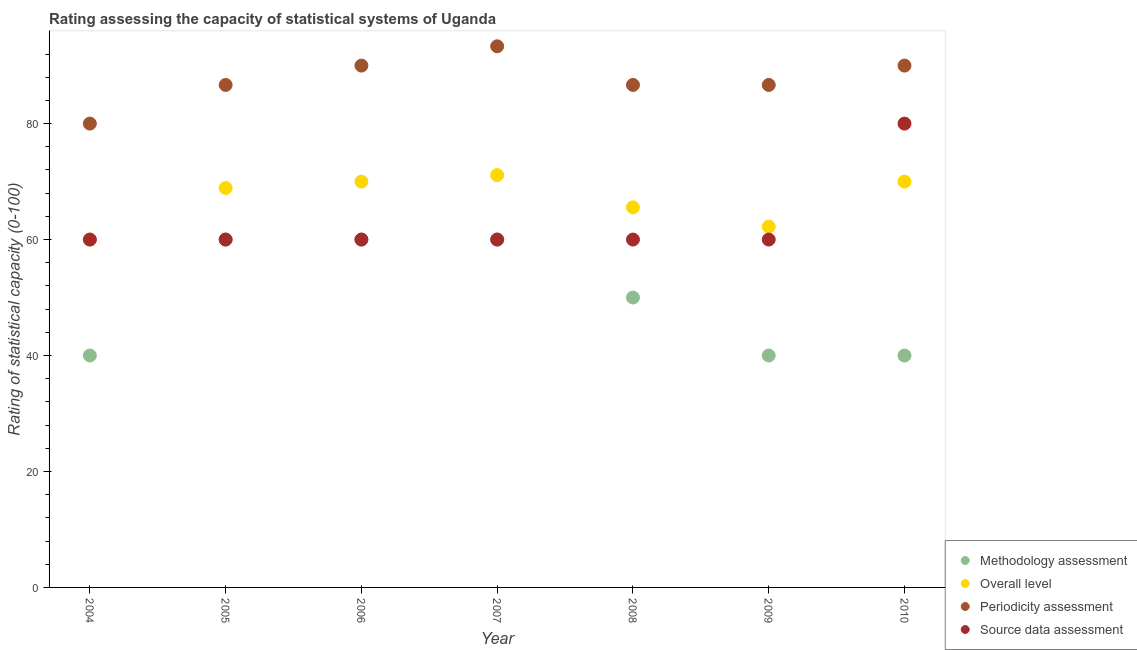How many different coloured dotlines are there?
Keep it short and to the point. 4. What is the source data assessment rating in 2008?
Your answer should be compact. 60. Across all years, what is the maximum overall level rating?
Keep it short and to the point. 71.11. Across all years, what is the minimum source data assessment rating?
Your answer should be compact. 60. In which year was the methodology assessment rating minimum?
Ensure brevity in your answer.  2004. What is the total overall level rating in the graph?
Ensure brevity in your answer.  467.78. What is the difference between the periodicity assessment rating in 2009 and that in 2010?
Ensure brevity in your answer.  -3.33. What is the difference between the periodicity assessment rating in 2005 and the source data assessment rating in 2009?
Ensure brevity in your answer.  26.67. What is the difference between the highest and the second highest source data assessment rating?
Keep it short and to the point. 20. What is the difference between the highest and the lowest source data assessment rating?
Offer a very short reply. 20. In how many years, is the overall level rating greater than the average overall level rating taken over all years?
Your response must be concise. 4. Is it the case that in every year, the sum of the methodology assessment rating and source data assessment rating is greater than the sum of periodicity assessment rating and overall level rating?
Your answer should be compact. No. Does the source data assessment rating monotonically increase over the years?
Provide a succinct answer. No. Is the source data assessment rating strictly greater than the overall level rating over the years?
Ensure brevity in your answer.  No. How many dotlines are there?
Offer a terse response. 4. What is the difference between two consecutive major ticks on the Y-axis?
Your answer should be very brief. 20. Are the values on the major ticks of Y-axis written in scientific E-notation?
Provide a short and direct response. No. Does the graph contain any zero values?
Your answer should be very brief. No. Where does the legend appear in the graph?
Your answer should be very brief. Bottom right. What is the title of the graph?
Your answer should be compact. Rating assessing the capacity of statistical systems of Uganda. What is the label or title of the X-axis?
Your response must be concise. Year. What is the label or title of the Y-axis?
Provide a short and direct response. Rating of statistical capacity (0-100). What is the Rating of statistical capacity (0-100) in Periodicity assessment in 2004?
Give a very brief answer. 80. What is the Rating of statistical capacity (0-100) in Source data assessment in 2004?
Offer a very short reply. 60. What is the Rating of statistical capacity (0-100) of Methodology assessment in 2005?
Offer a terse response. 60. What is the Rating of statistical capacity (0-100) in Overall level in 2005?
Make the answer very short. 68.89. What is the Rating of statistical capacity (0-100) of Periodicity assessment in 2005?
Make the answer very short. 86.67. What is the Rating of statistical capacity (0-100) of Source data assessment in 2005?
Offer a very short reply. 60. What is the Rating of statistical capacity (0-100) in Overall level in 2006?
Your answer should be very brief. 70. What is the Rating of statistical capacity (0-100) in Periodicity assessment in 2006?
Keep it short and to the point. 90. What is the Rating of statistical capacity (0-100) in Overall level in 2007?
Your answer should be very brief. 71.11. What is the Rating of statistical capacity (0-100) in Periodicity assessment in 2007?
Provide a succinct answer. 93.33. What is the Rating of statistical capacity (0-100) of Methodology assessment in 2008?
Your answer should be very brief. 50. What is the Rating of statistical capacity (0-100) of Overall level in 2008?
Keep it short and to the point. 65.56. What is the Rating of statistical capacity (0-100) in Periodicity assessment in 2008?
Offer a terse response. 86.67. What is the Rating of statistical capacity (0-100) of Source data assessment in 2008?
Offer a terse response. 60. What is the Rating of statistical capacity (0-100) in Overall level in 2009?
Your response must be concise. 62.22. What is the Rating of statistical capacity (0-100) in Periodicity assessment in 2009?
Give a very brief answer. 86.67. What is the Rating of statistical capacity (0-100) of Source data assessment in 2009?
Your answer should be compact. 60. What is the Rating of statistical capacity (0-100) of Source data assessment in 2010?
Give a very brief answer. 80. Across all years, what is the maximum Rating of statistical capacity (0-100) of Overall level?
Provide a short and direct response. 71.11. Across all years, what is the maximum Rating of statistical capacity (0-100) of Periodicity assessment?
Your answer should be very brief. 93.33. Across all years, what is the minimum Rating of statistical capacity (0-100) of Methodology assessment?
Your answer should be very brief. 40. Across all years, what is the minimum Rating of statistical capacity (0-100) in Periodicity assessment?
Offer a terse response. 80. Across all years, what is the minimum Rating of statistical capacity (0-100) of Source data assessment?
Provide a succinct answer. 60. What is the total Rating of statistical capacity (0-100) in Methodology assessment in the graph?
Give a very brief answer. 350. What is the total Rating of statistical capacity (0-100) in Overall level in the graph?
Your answer should be compact. 467.78. What is the total Rating of statistical capacity (0-100) in Periodicity assessment in the graph?
Your answer should be compact. 613.33. What is the total Rating of statistical capacity (0-100) in Source data assessment in the graph?
Make the answer very short. 440. What is the difference between the Rating of statistical capacity (0-100) in Methodology assessment in 2004 and that in 2005?
Keep it short and to the point. -20. What is the difference between the Rating of statistical capacity (0-100) of Overall level in 2004 and that in 2005?
Your answer should be very brief. -8.89. What is the difference between the Rating of statistical capacity (0-100) in Periodicity assessment in 2004 and that in 2005?
Your answer should be very brief. -6.67. What is the difference between the Rating of statistical capacity (0-100) in Source data assessment in 2004 and that in 2005?
Offer a terse response. 0. What is the difference between the Rating of statistical capacity (0-100) in Methodology assessment in 2004 and that in 2007?
Make the answer very short. -20. What is the difference between the Rating of statistical capacity (0-100) in Overall level in 2004 and that in 2007?
Give a very brief answer. -11.11. What is the difference between the Rating of statistical capacity (0-100) in Periodicity assessment in 2004 and that in 2007?
Ensure brevity in your answer.  -13.33. What is the difference between the Rating of statistical capacity (0-100) in Overall level in 2004 and that in 2008?
Keep it short and to the point. -5.56. What is the difference between the Rating of statistical capacity (0-100) of Periodicity assessment in 2004 and that in 2008?
Keep it short and to the point. -6.67. What is the difference between the Rating of statistical capacity (0-100) of Source data assessment in 2004 and that in 2008?
Offer a terse response. 0. What is the difference between the Rating of statistical capacity (0-100) of Overall level in 2004 and that in 2009?
Give a very brief answer. -2.22. What is the difference between the Rating of statistical capacity (0-100) of Periodicity assessment in 2004 and that in 2009?
Provide a succinct answer. -6.67. What is the difference between the Rating of statistical capacity (0-100) of Source data assessment in 2004 and that in 2009?
Your response must be concise. 0. What is the difference between the Rating of statistical capacity (0-100) of Periodicity assessment in 2004 and that in 2010?
Give a very brief answer. -10. What is the difference between the Rating of statistical capacity (0-100) in Source data assessment in 2004 and that in 2010?
Make the answer very short. -20. What is the difference between the Rating of statistical capacity (0-100) in Overall level in 2005 and that in 2006?
Make the answer very short. -1.11. What is the difference between the Rating of statistical capacity (0-100) in Source data assessment in 2005 and that in 2006?
Ensure brevity in your answer.  0. What is the difference between the Rating of statistical capacity (0-100) of Methodology assessment in 2005 and that in 2007?
Offer a terse response. 0. What is the difference between the Rating of statistical capacity (0-100) of Overall level in 2005 and that in 2007?
Keep it short and to the point. -2.22. What is the difference between the Rating of statistical capacity (0-100) in Periodicity assessment in 2005 and that in 2007?
Provide a short and direct response. -6.67. What is the difference between the Rating of statistical capacity (0-100) in Source data assessment in 2005 and that in 2007?
Make the answer very short. 0. What is the difference between the Rating of statistical capacity (0-100) in Overall level in 2005 and that in 2010?
Give a very brief answer. -1.11. What is the difference between the Rating of statistical capacity (0-100) of Periodicity assessment in 2005 and that in 2010?
Offer a very short reply. -3.33. What is the difference between the Rating of statistical capacity (0-100) of Source data assessment in 2005 and that in 2010?
Make the answer very short. -20. What is the difference between the Rating of statistical capacity (0-100) in Methodology assessment in 2006 and that in 2007?
Your response must be concise. 0. What is the difference between the Rating of statistical capacity (0-100) in Overall level in 2006 and that in 2007?
Provide a succinct answer. -1.11. What is the difference between the Rating of statistical capacity (0-100) in Periodicity assessment in 2006 and that in 2007?
Make the answer very short. -3.33. What is the difference between the Rating of statistical capacity (0-100) in Overall level in 2006 and that in 2008?
Make the answer very short. 4.44. What is the difference between the Rating of statistical capacity (0-100) of Methodology assessment in 2006 and that in 2009?
Offer a very short reply. 20. What is the difference between the Rating of statistical capacity (0-100) of Overall level in 2006 and that in 2009?
Your response must be concise. 7.78. What is the difference between the Rating of statistical capacity (0-100) of Source data assessment in 2006 and that in 2009?
Your answer should be very brief. 0. What is the difference between the Rating of statistical capacity (0-100) of Overall level in 2006 and that in 2010?
Provide a succinct answer. 0. What is the difference between the Rating of statistical capacity (0-100) of Overall level in 2007 and that in 2008?
Your response must be concise. 5.56. What is the difference between the Rating of statistical capacity (0-100) of Periodicity assessment in 2007 and that in 2008?
Provide a succinct answer. 6.67. What is the difference between the Rating of statistical capacity (0-100) of Source data assessment in 2007 and that in 2008?
Offer a very short reply. 0. What is the difference between the Rating of statistical capacity (0-100) in Methodology assessment in 2007 and that in 2009?
Give a very brief answer. 20. What is the difference between the Rating of statistical capacity (0-100) in Overall level in 2007 and that in 2009?
Make the answer very short. 8.89. What is the difference between the Rating of statistical capacity (0-100) in Periodicity assessment in 2007 and that in 2009?
Your answer should be compact. 6.67. What is the difference between the Rating of statistical capacity (0-100) of Source data assessment in 2007 and that in 2009?
Your response must be concise. 0. What is the difference between the Rating of statistical capacity (0-100) in Overall level in 2007 and that in 2010?
Make the answer very short. 1.11. What is the difference between the Rating of statistical capacity (0-100) in Methodology assessment in 2008 and that in 2010?
Give a very brief answer. 10. What is the difference between the Rating of statistical capacity (0-100) of Overall level in 2008 and that in 2010?
Ensure brevity in your answer.  -4.44. What is the difference between the Rating of statistical capacity (0-100) of Periodicity assessment in 2008 and that in 2010?
Make the answer very short. -3.33. What is the difference between the Rating of statistical capacity (0-100) of Overall level in 2009 and that in 2010?
Give a very brief answer. -7.78. What is the difference between the Rating of statistical capacity (0-100) in Source data assessment in 2009 and that in 2010?
Offer a terse response. -20. What is the difference between the Rating of statistical capacity (0-100) of Methodology assessment in 2004 and the Rating of statistical capacity (0-100) of Overall level in 2005?
Offer a terse response. -28.89. What is the difference between the Rating of statistical capacity (0-100) in Methodology assessment in 2004 and the Rating of statistical capacity (0-100) in Periodicity assessment in 2005?
Provide a succinct answer. -46.67. What is the difference between the Rating of statistical capacity (0-100) in Methodology assessment in 2004 and the Rating of statistical capacity (0-100) in Source data assessment in 2005?
Provide a short and direct response. -20. What is the difference between the Rating of statistical capacity (0-100) of Overall level in 2004 and the Rating of statistical capacity (0-100) of Periodicity assessment in 2005?
Your answer should be compact. -26.67. What is the difference between the Rating of statistical capacity (0-100) of Overall level in 2004 and the Rating of statistical capacity (0-100) of Source data assessment in 2005?
Your answer should be compact. 0. What is the difference between the Rating of statistical capacity (0-100) in Periodicity assessment in 2004 and the Rating of statistical capacity (0-100) in Source data assessment in 2005?
Your answer should be very brief. 20. What is the difference between the Rating of statistical capacity (0-100) in Methodology assessment in 2004 and the Rating of statistical capacity (0-100) in Overall level in 2006?
Give a very brief answer. -30. What is the difference between the Rating of statistical capacity (0-100) in Methodology assessment in 2004 and the Rating of statistical capacity (0-100) in Periodicity assessment in 2006?
Your response must be concise. -50. What is the difference between the Rating of statistical capacity (0-100) in Overall level in 2004 and the Rating of statistical capacity (0-100) in Source data assessment in 2006?
Give a very brief answer. 0. What is the difference between the Rating of statistical capacity (0-100) in Methodology assessment in 2004 and the Rating of statistical capacity (0-100) in Overall level in 2007?
Your answer should be compact. -31.11. What is the difference between the Rating of statistical capacity (0-100) of Methodology assessment in 2004 and the Rating of statistical capacity (0-100) of Periodicity assessment in 2007?
Make the answer very short. -53.33. What is the difference between the Rating of statistical capacity (0-100) in Methodology assessment in 2004 and the Rating of statistical capacity (0-100) in Source data assessment in 2007?
Make the answer very short. -20. What is the difference between the Rating of statistical capacity (0-100) of Overall level in 2004 and the Rating of statistical capacity (0-100) of Periodicity assessment in 2007?
Keep it short and to the point. -33.33. What is the difference between the Rating of statistical capacity (0-100) of Periodicity assessment in 2004 and the Rating of statistical capacity (0-100) of Source data assessment in 2007?
Keep it short and to the point. 20. What is the difference between the Rating of statistical capacity (0-100) of Methodology assessment in 2004 and the Rating of statistical capacity (0-100) of Overall level in 2008?
Your response must be concise. -25.56. What is the difference between the Rating of statistical capacity (0-100) in Methodology assessment in 2004 and the Rating of statistical capacity (0-100) in Periodicity assessment in 2008?
Provide a short and direct response. -46.67. What is the difference between the Rating of statistical capacity (0-100) in Overall level in 2004 and the Rating of statistical capacity (0-100) in Periodicity assessment in 2008?
Make the answer very short. -26.67. What is the difference between the Rating of statistical capacity (0-100) of Overall level in 2004 and the Rating of statistical capacity (0-100) of Source data assessment in 2008?
Make the answer very short. 0. What is the difference between the Rating of statistical capacity (0-100) in Periodicity assessment in 2004 and the Rating of statistical capacity (0-100) in Source data assessment in 2008?
Provide a succinct answer. 20. What is the difference between the Rating of statistical capacity (0-100) in Methodology assessment in 2004 and the Rating of statistical capacity (0-100) in Overall level in 2009?
Provide a succinct answer. -22.22. What is the difference between the Rating of statistical capacity (0-100) in Methodology assessment in 2004 and the Rating of statistical capacity (0-100) in Periodicity assessment in 2009?
Your response must be concise. -46.67. What is the difference between the Rating of statistical capacity (0-100) of Methodology assessment in 2004 and the Rating of statistical capacity (0-100) of Source data assessment in 2009?
Provide a succinct answer. -20. What is the difference between the Rating of statistical capacity (0-100) in Overall level in 2004 and the Rating of statistical capacity (0-100) in Periodicity assessment in 2009?
Make the answer very short. -26.67. What is the difference between the Rating of statistical capacity (0-100) of Overall level in 2004 and the Rating of statistical capacity (0-100) of Source data assessment in 2009?
Make the answer very short. 0. What is the difference between the Rating of statistical capacity (0-100) in Methodology assessment in 2004 and the Rating of statistical capacity (0-100) in Overall level in 2010?
Your answer should be very brief. -30. What is the difference between the Rating of statistical capacity (0-100) in Overall level in 2004 and the Rating of statistical capacity (0-100) in Periodicity assessment in 2010?
Offer a very short reply. -30. What is the difference between the Rating of statistical capacity (0-100) of Periodicity assessment in 2004 and the Rating of statistical capacity (0-100) of Source data assessment in 2010?
Offer a terse response. 0. What is the difference between the Rating of statistical capacity (0-100) in Methodology assessment in 2005 and the Rating of statistical capacity (0-100) in Overall level in 2006?
Your answer should be very brief. -10. What is the difference between the Rating of statistical capacity (0-100) in Overall level in 2005 and the Rating of statistical capacity (0-100) in Periodicity assessment in 2006?
Your answer should be compact. -21.11. What is the difference between the Rating of statistical capacity (0-100) in Overall level in 2005 and the Rating of statistical capacity (0-100) in Source data assessment in 2006?
Ensure brevity in your answer.  8.89. What is the difference between the Rating of statistical capacity (0-100) of Periodicity assessment in 2005 and the Rating of statistical capacity (0-100) of Source data assessment in 2006?
Ensure brevity in your answer.  26.67. What is the difference between the Rating of statistical capacity (0-100) in Methodology assessment in 2005 and the Rating of statistical capacity (0-100) in Overall level in 2007?
Your answer should be very brief. -11.11. What is the difference between the Rating of statistical capacity (0-100) of Methodology assessment in 2005 and the Rating of statistical capacity (0-100) of Periodicity assessment in 2007?
Your answer should be very brief. -33.33. What is the difference between the Rating of statistical capacity (0-100) of Methodology assessment in 2005 and the Rating of statistical capacity (0-100) of Source data assessment in 2007?
Offer a terse response. 0. What is the difference between the Rating of statistical capacity (0-100) in Overall level in 2005 and the Rating of statistical capacity (0-100) in Periodicity assessment in 2007?
Keep it short and to the point. -24.44. What is the difference between the Rating of statistical capacity (0-100) of Overall level in 2005 and the Rating of statistical capacity (0-100) of Source data assessment in 2007?
Your response must be concise. 8.89. What is the difference between the Rating of statistical capacity (0-100) of Periodicity assessment in 2005 and the Rating of statistical capacity (0-100) of Source data assessment in 2007?
Offer a terse response. 26.67. What is the difference between the Rating of statistical capacity (0-100) in Methodology assessment in 2005 and the Rating of statistical capacity (0-100) in Overall level in 2008?
Offer a very short reply. -5.56. What is the difference between the Rating of statistical capacity (0-100) of Methodology assessment in 2005 and the Rating of statistical capacity (0-100) of Periodicity assessment in 2008?
Your answer should be compact. -26.67. What is the difference between the Rating of statistical capacity (0-100) of Overall level in 2005 and the Rating of statistical capacity (0-100) of Periodicity assessment in 2008?
Your answer should be compact. -17.78. What is the difference between the Rating of statistical capacity (0-100) of Overall level in 2005 and the Rating of statistical capacity (0-100) of Source data assessment in 2008?
Provide a short and direct response. 8.89. What is the difference between the Rating of statistical capacity (0-100) in Periodicity assessment in 2005 and the Rating of statistical capacity (0-100) in Source data assessment in 2008?
Offer a very short reply. 26.67. What is the difference between the Rating of statistical capacity (0-100) in Methodology assessment in 2005 and the Rating of statistical capacity (0-100) in Overall level in 2009?
Provide a short and direct response. -2.22. What is the difference between the Rating of statistical capacity (0-100) of Methodology assessment in 2005 and the Rating of statistical capacity (0-100) of Periodicity assessment in 2009?
Your answer should be very brief. -26.67. What is the difference between the Rating of statistical capacity (0-100) of Overall level in 2005 and the Rating of statistical capacity (0-100) of Periodicity assessment in 2009?
Keep it short and to the point. -17.78. What is the difference between the Rating of statistical capacity (0-100) in Overall level in 2005 and the Rating of statistical capacity (0-100) in Source data assessment in 2009?
Offer a terse response. 8.89. What is the difference between the Rating of statistical capacity (0-100) in Periodicity assessment in 2005 and the Rating of statistical capacity (0-100) in Source data assessment in 2009?
Keep it short and to the point. 26.67. What is the difference between the Rating of statistical capacity (0-100) in Overall level in 2005 and the Rating of statistical capacity (0-100) in Periodicity assessment in 2010?
Your answer should be compact. -21.11. What is the difference between the Rating of statistical capacity (0-100) in Overall level in 2005 and the Rating of statistical capacity (0-100) in Source data assessment in 2010?
Ensure brevity in your answer.  -11.11. What is the difference between the Rating of statistical capacity (0-100) in Periodicity assessment in 2005 and the Rating of statistical capacity (0-100) in Source data assessment in 2010?
Ensure brevity in your answer.  6.67. What is the difference between the Rating of statistical capacity (0-100) in Methodology assessment in 2006 and the Rating of statistical capacity (0-100) in Overall level in 2007?
Your answer should be very brief. -11.11. What is the difference between the Rating of statistical capacity (0-100) in Methodology assessment in 2006 and the Rating of statistical capacity (0-100) in Periodicity assessment in 2007?
Your response must be concise. -33.33. What is the difference between the Rating of statistical capacity (0-100) in Overall level in 2006 and the Rating of statistical capacity (0-100) in Periodicity assessment in 2007?
Your response must be concise. -23.33. What is the difference between the Rating of statistical capacity (0-100) of Overall level in 2006 and the Rating of statistical capacity (0-100) of Source data assessment in 2007?
Your answer should be very brief. 10. What is the difference between the Rating of statistical capacity (0-100) in Methodology assessment in 2006 and the Rating of statistical capacity (0-100) in Overall level in 2008?
Keep it short and to the point. -5.56. What is the difference between the Rating of statistical capacity (0-100) of Methodology assessment in 2006 and the Rating of statistical capacity (0-100) of Periodicity assessment in 2008?
Offer a very short reply. -26.67. What is the difference between the Rating of statistical capacity (0-100) in Overall level in 2006 and the Rating of statistical capacity (0-100) in Periodicity assessment in 2008?
Your answer should be very brief. -16.67. What is the difference between the Rating of statistical capacity (0-100) of Periodicity assessment in 2006 and the Rating of statistical capacity (0-100) of Source data assessment in 2008?
Give a very brief answer. 30. What is the difference between the Rating of statistical capacity (0-100) in Methodology assessment in 2006 and the Rating of statistical capacity (0-100) in Overall level in 2009?
Your answer should be compact. -2.22. What is the difference between the Rating of statistical capacity (0-100) in Methodology assessment in 2006 and the Rating of statistical capacity (0-100) in Periodicity assessment in 2009?
Ensure brevity in your answer.  -26.67. What is the difference between the Rating of statistical capacity (0-100) in Methodology assessment in 2006 and the Rating of statistical capacity (0-100) in Source data assessment in 2009?
Keep it short and to the point. 0. What is the difference between the Rating of statistical capacity (0-100) of Overall level in 2006 and the Rating of statistical capacity (0-100) of Periodicity assessment in 2009?
Ensure brevity in your answer.  -16.67. What is the difference between the Rating of statistical capacity (0-100) of Overall level in 2006 and the Rating of statistical capacity (0-100) of Source data assessment in 2009?
Your response must be concise. 10. What is the difference between the Rating of statistical capacity (0-100) in Methodology assessment in 2006 and the Rating of statistical capacity (0-100) in Overall level in 2010?
Ensure brevity in your answer.  -10. What is the difference between the Rating of statistical capacity (0-100) in Methodology assessment in 2006 and the Rating of statistical capacity (0-100) in Periodicity assessment in 2010?
Offer a very short reply. -30. What is the difference between the Rating of statistical capacity (0-100) of Overall level in 2006 and the Rating of statistical capacity (0-100) of Periodicity assessment in 2010?
Keep it short and to the point. -20. What is the difference between the Rating of statistical capacity (0-100) of Periodicity assessment in 2006 and the Rating of statistical capacity (0-100) of Source data assessment in 2010?
Make the answer very short. 10. What is the difference between the Rating of statistical capacity (0-100) in Methodology assessment in 2007 and the Rating of statistical capacity (0-100) in Overall level in 2008?
Offer a terse response. -5.56. What is the difference between the Rating of statistical capacity (0-100) in Methodology assessment in 2007 and the Rating of statistical capacity (0-100) in Periodicity assessment in 2008?
Your answer should be very brief. -26.67. What is the difference between the Rating of statistical capacity (0-100) of Overall level in 2007 and the Rating of statistical capacity (0-100) of Periodicity assessment in 2008?
Provide a short and direct response. -15.56. What is the difference between the Rating of statistical capacity (0-100) in Overall level in 2007 and the Rating of statistical capacity (0-100) in Source data assessment in 2008?
Your response must be concise. 11.11. What is the difference between the Rating of statistical capacity (0-100) in Periodicity assessment in 2007 and the Rating of statistical capacity (0-100) in Source data assessment in 2008?
Your answer should be compact. 33.33. What is the difference between the Rating of statistical capacity (0-100) in Methodology assessment in 2007 and the Rating of statistical capacity (0-100) in Overall level in 2009?
Your answer should be very brief. -2.22. What is the difference between the Rating of statistical capacity (0-100) of Methodology assessment in 2007 and the Rating of statistical capacity (0-100) of Periodicity assessment in 2009?
Ensure brevity in your answer.  -26.67. What is the difference between the Rating of statistical capacity (0-100) in Methodology assessment in 2007 and the Rating of statistical capacity (0-100) in Source data assessment in 2009?
Your answer should be compact. 0. What is the difference between the Rating of statistical capacity (0-100) in Overall level in 2007 and the Rating of statistical capacity (0-100) in Periodicity assessment in 2009?
Provide a short and direct response. -15.56. What is the difference between the Rating of statistical capacity (0-100) in Overall level in 2007 and the Rating of statistical capacity (0-100) in Source data assessment in 2009?
Your response must be concise. 11.11. What is the difference between the Rating of statistical capacity (0-100) of Periodicity assessment in 2007 and the Rating of statistical capacity (0-100) of Source data assessment in 2009?
Make the answer very short. 33.33. What is the difference between the Rating of statistical capacity (0-100) in Methodology assessment in 2007 and the Rating of statistical capacity (0-100) in Source data assessment in 2010?
Keep it short and to the point. -20. What is the difference between the Rating of statistical capacity (0-100) of Overall level in 2007 and the Rating of statistical capacity (0-100) of Periodicity assessment in 2010?
Make the answer very short. -18.89. What is the difference between the Rating of statistical capacity (0-100) of Overall level in 2007 and the Rating of statistical capacity (0-100) of Source data assessment in 2010?
Your answer should be very brief. -8.89. What is the difference between the Rating of statistical capacity (0-100) in Periodicity assessment in 2007 and the Rating of statistical capacity (0-100) in Source data assessment in 2010?
Offer a very short reply. 13.33. What is the difference between the Rating of statistical capacity (0-100) of Methodology assessment in 2008 and the Rating of statistical capacity (0-100) of Overall level in 2009?
Keep it short and to the point. -12.22. What is the difference between the Rating of statistical capacity (0-100) of Methodology assessment in 2008 and the Rating of statistical capacity (0-100) of Periodicity assessment in 2009?
Offer a terse response. -36.67. What is the difference between the Rating of statistical capacity (0-100) of Overall level in 2008 and the Rating of statistical capacity (0-100) of Periodicity assessment in 2009?
Your response must be concise. -21.11. What is the difference between the Rating of statistical capacity (0-100) in Overall level in 2008 and the Rating of statistical capacity (0-100) in Source data assessment in 2009?
Offer a very short reply. 5.56. What is the difference between the Rating of statistical capacity (0-100) of Periodicity assessment in 2008 and the Rating of statistical capacity (0-100) of Source data assessment in 2009?
Offer a terse response. 26.67. What is the difference between the Rating of statistical capacity (0-100) in Methodology assessment in 2008 and the Rating of statistical capacity (0-100) in Periodicity assessment in 2010?
Give a very brief answer. -40. What is the difference between the Rating of statistical capacity (0-100) of Methodology assessment in 2008 and the Rating of statistical capacity (0-100) of Source data assessment in 2010?
Provide a succinct answer. -30. What is the difference between the Rating of statistical capacity (0-100) of Overall level in 2008 and the Rating of statistical capacity (0-100) of Periodicity assessment in 2010?
Provide a short and direct response. -24.44. What is the difference between the Rating of statistical capacity (0-100) of Overall level in 2008 and the Rating of statistical capacity (0-100) of Source data assessment in 2010?
Provide a succinct answer. -14.44. What is the difference between the Rating of statistical capacity (0-100) of Methodology assessment in 2009 and the Rating of statistical capacity (0-100) of Overall level in 2010?
Your answer should be very brief. -30. What is the difference between the Rating of statistical capacity (0-100) of Methodology assessment in 2009 and the Rating of statistical capacity (0-100) of Source data assessment in 2010?
Ensure brevity in your answer.  -40. What is the difference between the Rating of statistical capacity (0-100) of Overall level in 2009 and the Rating of statistical capacity (0-100) of Periodicity assessment in 2010?
Your answer should be very brief. -27.78. What is the difference between the Rating of statistical capacity (0-100) in Overall level in 2009 and the Rating of statistical capacity (0-100) in Source data assessment in 2010?
Give a very brief answer. -17.78. What is the difference between the Rating of statistical capacity (0-100) in Periodicity assessment in 2009 and the Rating of statistical capacity (0-100) in Source data assessment in 2010?
Your response must be concise. 6.67. What is the average Rating of statistical capacity (0-100) of Methodology assessment per year?
Ensure brevity in your answer.  50. What is the average Rating of statistical capacity (0-100) in Overall level per year?
Offer a terse response. 66.83. What is the average Rating of statistical capacity (0-100) of Periodicity assessment per year?
Offer a terse response. 87.62. What is the average Rating of statistical capacity (0-100) in Source data assessment per year?
Your answer should be compact. 62.86. In the year 2004, what is the difference between the Rating of statistical capacity (0-100) in Overall level and Rating of statistical capacity (0-100) in Source data assessment?
Your answer should be very brief. 0. In the year 2005, what is the difference between the Rating of statistical capacity (0-100) of Methodology assessment and Rating of statistical capacity (0-100) of Overall level?
Make the answer very short. -8.89. In the year 2005, what is the difference between the Rating of statistical capacity (0-100) in Methodology assessment and Rating of statistical capacity (0-100) in Periodicity assessment?
Offer a terse response. -26.67. In the year 2005, what is the difference between the Rating of statistical capacity (0-100) of Overall level and Rating of statistical capacity (0-100) of Periodicity assessment?
Keep it short and to the point. -17.78. In the year 2005, what is the difference between the Rating of statistical capacity (0-100) of Overall level and Rating of statistical capacity (0-100) of Source data assessment?
Your response must be concise. 8.89. In the year 2005, what is the difference between the Rating of statistical capacity (0-100) in Periodicity assessment and Rating of statistical capacity (0-100) in Source data assessment?
Provide a short and direct response. 26.67. In the year 2006, what is the difference between the Rating of statistical capacity (0-100) of Methodology assessment and Rating of statistical capacity (0-100) of Periodicity assessment?
Give a very brief answer. -30. In the year 2006, what is the difference between the Rating of statistical capacity (0-100) in Overall level and Rating of statistical capacity (0-100) in Periodicity assessment?
Your answer should be compact. -20. In the year 2006, what is the difference between the Rating of statistical capacity (0-100) of Overall level and Rating of statistical capacity (0-100) of Source data assessment?
Provide a succinct answer. 10. In the year 2007, what is the difference between the Rating of statistical capacity (0-100) in Methodology assessment and Rating of statistical capacity (0-100) in Overall level?
Your answer should be compact. -11.11. In the year 2007, what is the difference between the Rating of statistical capacity (0-100) of Methodology assessment and Rating of statistical capacity (0-100) of Periodicity assessment?
Offer a terse response. -33.33. In the year 2007, what is the difference between the Rating of statistical capacity (0-100) of Methodology assessment and Rating of statistical capacity (0-100) of Source data assessment?
Your response must be concise. 0. In the year 2007, what is the difference between the Rating of statistical capacity (0-100) in Overall level and Rating of statistical capacity (0-100) in Periodicity assessment?
Keep it short and to the point. -22.22. In the year 2007, what is the difference between the Rating of statistical capacity (0-100) of Overall level and Rating of statistical capacity (0-100) of Source data assessment?
Offer a terse response. 11.11. In the year 2007, what is the difference between the Rating of statistical capacity (0-100) of Periodicity assessment and Rating of statistical capacity (0-100) of Source data assessment?
Ensure brevity in your answer.  33.33. In the year 2008, what is the difference between the Rating of statistical capacity (0-100) in Methodology assessment and Rating of statistical capacity (0-100) in Overall level?
Give a very brief answer. -15.56. In the year 2008, what is the difference between the Rating of statistical capacity (0-100) in Methodology assessment and Rating of statistical capacity (0-100) in Periodicity assessment?
Give a very brief answer. -36.67. In the year 2008, what is the difference between the Rating of statistical capacity (0-100) of Overall level and Rating of statistical capacity (0-100) of Periodicity assessment?
Your answer should be very brief. -21.11. In the year 2008, what is the difference between the Rating of statistical capacity (0-100) in Overall level and Rating of statistical capacity (0-100) in Source data assessment?
Provide a short and direct response. 5.56. In the year 2008, what is the difference between the Rating of statistical capacity (0-100) in Periodicity assessment and Rating of statistical capacity (0-100) in Source data assessment?
Make the answer very short. 26.67. In the year 2009, what is the difference between the Rating of statistical capacity (0-100) in Methodology assessment and Rating of statistical capacity (0-100) in Overall level?
Make the answer very short. -22.22. In the year 2009, what is the difference between the Rating of statistical capacity (0-100) of Methodology assessment and Rating of statistical capacity (0-100) of Periodicity assessment?
Provide a short and direct response. -46.67. In the year 2009, what is the difference between the Rating of statistical capacity (0-100) of Methodology assessment and Rating of statistical capacity (0-100) of Source data assessment?
Offer a terse response. -20. In the year 2009, what is the difference between the Rating of statistical capacity (0-100) of Overall level and Rating of statistical capacity (0-100) of Periodicity assessment?
Ensure brevity in your answer.  -24.44. In the year 2009, what is the difference between the Rating of statistical capacity (0-100) in Overall level and Rating of statistical capacity (0-100) in Source data assessment?
Offer a terse response. 2.22. In the year 2009, what is the difference between the Rating of statistical capacity (0-100) of Periodicity assessment and Rating of statistical capacity (0-100) of Source data assessment?
Ensure brevity in your answer.  26.67. In the year 2010, what is the difference between the Rating of statistical capacity (0-100) of Methodology assessment and Rating of statistical capacity (0-100) of Overall level?
Make the answer very short. -30. In the year 2010, what is the difference between the Rating of statistical capacity (0-100) of Methodology assessment and Rating of statistical capacity (0-100) of Periodicity assessment?
Ensure brevity in your answer.  -50. In the year 2010, what is the difference between the Rating of statistical capacity (0-100) of Methodology assessment and Rating of statistical capacity (0-100) of Source data assessment?
Your response must be concise. -40. In the year 2010, what is the difference between the Rating of statistical capacity (0-100) of Overall level and Rating of statistical capacity (0-100) of Source data assessment?
Your answer should be very brief. -10. What is the ratio of the Rating of statistical capacity (0-100) of Overall level in 2004 to that in 2005?
Ensure brevity in your answer.  0.87. What is the ratio of the Rating of statistical capacity (0-100) of Periodicity assessment in 2004 to that in 2005?
Provide a short and direct response. 0.92. What is the ratio of the Rating of statistical capacity (0-100) of Methodology assessment in 2004 to that in 2006?
Make the answer very short. 0.67. What is the ratio of the Rating of statistical capacity (0-100) in Overall level in 2004 to that in 2006?
Give a very brief answer. 0.86. What is the ratio of the Rating of statistical capacity (0-100) in Methodology assessment in 2004 to that in 2007?
Provide a short and direct response. 0.67. What is the ratio of the Rating of statistical capacity (0-100) in Overall level in 2004 to that in 2007?
Your response must be concise. 0.84. What is the ratio of the Rating of statistical capacity (0-100) of Source data assessment in 2004 to that in 2007?
Your answer should be very brief. 1. What is the ratio of the Rating of statistical capacity (0-100) in Methodology assessment in 2004 to that in 2008?
Offer a terse response. 0.8. What is the ratio of the Rating of statistical capacity (0-100) of Overall level in 2004 to that in 2008?
Offer a terse response. 0.92. What is the ratio of the Rating of statistical capacity (0-100) of Periodicity assessment in 2004 to that in 2008?
Your answer should be compact. 0.92. What is the ratio of the Rating of statistical capacity (0-100) in Overall level in 2004 to that in 2009?
Give a very brief answer. 0.96. What is the ratio of the Rating of statistical capacity (0-100) of Source data assessment in 2004 to that in 2009?
Offer a terse response. 1. What is the ratio of the Rating of statistical capacity (0-100) in Overall level in 2004 to that in 2010?
Your answer should be compact. 0.86. What is the ratio of the Rating of statistical capacity (0-100) in Methodology assessment in 2005 to that in 2006?
Your answer should be compact. 1. What is the ratio of the Rating of statistical capacity (0-100) of Overall level in 2005 to that in 2006?
Your answer should be compact. 0.98. What is the ratio of the Rating of statistical capacity (0-100) of Periodicity assessment in 2005 to that in 2006?
Your response must be concise. 0.96. What is the ratio of the Rating of statistical capacity (0-100) of Source data assessment in 2005 to that in 2006?
Provide a short and direct response. 1. What is the ratio of the Rating of statistical capacity (0-100) of Overall level in 2005 to that in 2007?
Offer a very short reply. 0.97. What is the ratio of the Rating of statistical capacity (0-100) in Periodicity assessment in 2005 to that in 2007?
Keep it short and to the point. 0.93. What is the ratio of the Rating of statistical capacity (0-100) in Overall level in 2005 to that in 2008?
Offer a terse response. 1.05. What is the ratio of the Rating of statistical capacity (0-100) in Periodicity assessment in 2005 to that in 2008?
Make the answer very short. 1. What is the ratio of the Rating of statistical capacity (0-100) in Overall level in 2005 to that in 2009?
Offer a very short reply. 1.11. What is the ratio of the Rating of statistical capacity (0-100) in Overall level in 2005 to that in 2010?
Provide a short and direct response. 0.98. What is the ratio of the Rating of statistical capacity (0-100) in Source data assessment in 2005 to that in 2010?
Ensure brevity in your answer.  0.75. What is the ratio of the Rating of statistical capacity (0-100) of Overall level in 2006 to that in 2007?
Ensure brevity in your answer.  0.98. What is the ratio of the Rating of statistical capacity (0-100) in Periodicity assessment in 2006 to that in 2007?
Your response must be concise. 0.96. What is the ratio of the Rating of statistical capacity (0-100) of Overall level in 2006 to that in 2008?
Ensure brevity in your answer.  1.07. What is the ratio of the Rating of statistical capacity (0-100) of Periodicity assessment in 2006 to that in 2008?
Ensure brevity in your answer.  1.04. What is the ratio of the Rating of statistical capacity (0-100) in Source data assessment in 2006 to that in 2008?
Provide a short and direct response. 1. What is the ratio of the Rating of statistical capacity (0-100) in Methodology assessment in 2006 to that in 2009?
Provide a short and direct response. 1.5. What is the ratio of the Rating of statistical capacity (0-100) of Overall level in 2006 to that in 2009?
Ensure brevity in your answer.  1.12. What is the ratio of the Rating of statistical capacity (0-100) in Periodicity assessment in 2006 to that in 2009?
Offer a very short reply. 1.04. What is the ratio of the Rating of statistical capacity (0-100) in Methodology assessment in 2006 to that in 2010?
Your response must be concise. 1.5. What is the ratio of the Rating of statistical capacity (0-100) in Overall level in 2006 to that in 2010?
Make the answer very short. 1. What is the ratio of the Rating of statistical capacity (0-100) in Source data assessment in 2006 to that in 2010?
Offer a terse response. 0.75. What is the ratio of the Rating of statistical capacity (0-100) of Methodology assessment in 2007 to that in 2008?
Provide a short and direct response. 1.2. What is the ratio of the Rating of statistical capacity (0-100) in Overall level in 2007 to that in 2008?
Your answer should be very brief. 1.08. What is the ratio of the Rating of statistical capacity (0-100) of Periodicity assessment in 2007 to that in 2008?
Your response must be concise. 1.08. What is the ratio of the Rating of statistical capacity (0-100) of Source data assessment in 2007 to that in 2008?
Offer a very short reply. 1. What is the ratio of the Rating of statistical capacity (0-100) of Methodology assessment in 2007 to that in 2009?
Offer a very short reply. 1.5. What is the ratio of the Rating of statistical capacity (0-100) of Periodicity assessment in 2007 to that in 2009?
Keep it short and to the point. 1.08. What is the ratio of the Rating of statistical capacity (0-100) of Source data assessment in 2007 to that in 2009?
Make the answer very short. 1. What is the ratio of the Rating of statistical capacity (0-100) in Overall level in 2007 to that in 2010?
Give a very brief answer. 1.02. What is the ratio of the Rating of statistical capacity (0-100) in Overall level in 2008 to that in 2009?
Provide a succinct answer. 1.05. What is the ratio of the Rating of statistical capacity (0-100) of Periodicity assessment in 2008 to that in 2009?
Offer a very short reply. 1. What is the ratio of the Rating of statistical capacity (0-100) in Overall level in 2008 to that in 2010?
Offer a terse response. 0.94. What is the ratio of the Rating of statistical capacity (0-100) in Periodicity assessment in 2008 to that in 2010?
Ensure brevity in your answer.  0.96. What is the ratio of the Rating of statistical capacity (0-100) of Methodology assessment in 2009 to that in 2010?
Provide a short and direct response. 1. What is the ratio of the Rating of statistical capacity (0-100) in Source data assessment in 2009 to that in 2010?
Your answer should be compact. 0.75. What is the difference between the highest and the second highest Rating of statistical capacity (0-100) in Periodicity assessment?
Your answer should be very brief. 3.33. What is the difference between the highest and the lowest Rating of statistical capacity (0-100) in Overall level?
Provide a short and direct response. 11.11. What is the difference between the highest and the lowest Rating of statistical capacity (0-100) in Periodicity assessment?
Your answer should be very brief. 13.33. What is the difference between the highest and the lowest Rating of statistical capacity (0-100) in Source data assessment?
Offer a terse response. 20. 